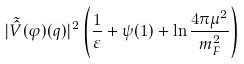Convert formula to latex. <formula><loc_0><loc_0><loc_500><loc_500>| \tilde { \hat { V } } ( \varphi ) ( q ) | ^ { 2 } \left ( \frac { 1 } { \varepsilon } + \psi ( 1 ) + \ln \frac { 4 \pi \mu ^ { 2 } } { m _ { F } ^ { 2 } } \right )</formula> 